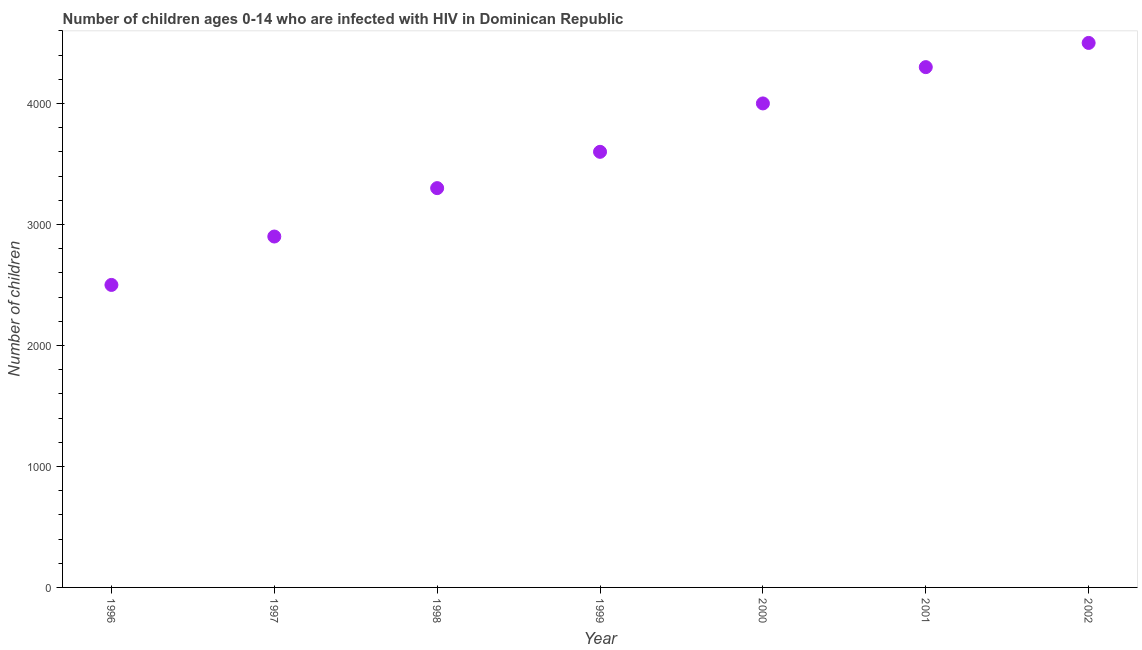What is the number of children living with hiv in 1997?
Your response must be concise. 2900. Across all years, what is the maximum number of children living with hiv?
Your answer should be compact. 4500. Across all years, what is the minimum number of children living with hiv?
Keep it short and to the point. 2500. In which year was the number of children living with hiv maximum?
Your answer should be compact. 2002. In which year was the number of children living with hiv minimum?
Offer a very short reply. 1996. What is the sum of the number of children living with hiv?
Keep it short and to the point. 2.51e+04. What is the difference between the number of children living with hiv in 1998 and 2002?
Your answer should be compact. -1200. What is the average number of children living with hiv per year?
Ensure brevity in your answer.  3585.71. What is the median number of children living with hiv?
Your answer should be compact. 3600. Do a majority of the years between 2001 and 1996 (inclusive) have number of children living with hiv greater than 1800 ?
Your answer should be compact. Yes. What is the ratio of the number of children living with hiv in 1996 to that in 1998?
Provide a short and direct response. 0.76. Is the number of children living with hiv in 1997 less than that in 2001?
Make the answer very short. Yes. Is the difference between the number of children living with hiv in 2001 and 2002 greater than the difference between any two years?
Make the answer very short. No. What is the difference between the highest and the lowest number of children living with hiv?
Keep it short and to the point. 2000. Does the number of children living with hiv monotonically increase over the years?
Your answer should be compact. Yes. Are the values on the major ticks of Y-axis written in scientific E-notation?
Offer a terse response. No. Does the graph contain any zero values?
Your response must be concise. No. Does the graph contain grids?
Offer a terse response. No. What is the title of the graph?
Keep it short and to the point. Number of children ages 0-14 who are infected with HIV in Dominican Republic. What is the label or title of the X-axis?
Keep it short and to the point. Year. What is the label or title of the Y-axis?
Offer a very short reply. Number of children. What is the Number of children in 1996?
Your answer should be compact. 2500. What is the Number of children in 1997?
Provide a succinct answer. 2900. What is the Number of children in 1998?
Make the answer very short. 3300. What is the Number of children in 1999?
Your answer should be very brief. 3600. What is the Number of children in 2000?
Keep it short and to the point. 4000. What is the Number of children in 2001?
Ensure brevity in your answer.  4300. What is the Number of children in 2002?
Your answer should be compact. 4500. What is the difference between the Number of children in 1996 and 1997?
Ensure brevity in your answer.  -400. What is the difference between the Number of children in 1996 and 1998?
Make the answer very short. -800. What is the difference between the Number of children in 1996 and 1999?
Your answer should be compact. -1100. What is the difference between the Number of children in 1996 and 2000?
Give a very brief answer. -1500. What is the difference between the Number of children in 1996 and 2001?
Your answer should be compact. -1800. What is the difference between the Number of children in 1996 and 2002?
Provide a succinct answer. -2000. What is the difference between the Number of children in 1997 and 1998?
Your answer should be compact. -400. What is the difference between the Number of children in 1997 and 1999?
Offer a terse response. -700. What is the difference between the Number of children in 1997 and 2000?
Provide a short and direct response. -1100. What is the difference between the Number of children in 1997 and 2001?
Your response must be concise. -1400. What is the difference between the Number of children in 1997 and 2002?
Offer a terse response. -1600. What is the difference between the Number of children in 1998 and 1999?
Your answer should be very brief. -300. What is the difference between the Number of children in 1998 and 2000?
Offer a very short reply. -700. What is the difference between the Number of children in 1998 and 2001?
Keep it short and to the point. -1000. What is the difference between the Number of children in 1998 and 2002?
Offer a terse response. -1200. What is the difference between the Number of children in 1999 and 2000?
Your answer should be compact. -400. What is the difference between the Number of children in 1999 and 2001?
Give a very brief answer. -700. What is the difference between the Number of children in 1999 and 2002?
Offer a very short reply. -900. What is the difference between the Number of children in 2000 and 2001?
Your answer should be compact. -300. What is the difference between the Number of children in 2000 and 2002?
Provide a short and direct response. -500. What is the difference between the Number of children in 2001 and 2002?
Ensure brevity in your answer.  -200. What is the ratio of the Number of children in 1996 to that in 1997?
Provide a short and direct response. 0.86. What is the ratio of the Number of children in 1996 to that in 1998?
Make the answer very short. 0.76. What is the ratio of the Number of children in 1996 to that in 1999?
Your response must be concise. 0.69. What is the ratio of the Number of children in 1996 to that in 2000?
Make the answer very short. 0.62. What is the ratio of the Number of children in 1996 to that in 2001?
Your response must be concise. 0.58. What is the ratio of the Number of children in 1996 to that in 2002?
Offer a terse response. 0.56. What is the ratio of the Number of children in 1997 to that in 1998?
Offer a very short reply. 0.88. What is the ratio of the Number of children in 1997 to that in 1999?
Give a very brief answer. 0.81. What is the ratio of the Number of children in 1997 to that in 2000?
Your response must be concise. 0.72. What is the ratio of the Number of children in 1997 to that in 2001?
Make the answer very short. 0.67. What is the ratio of the Number of children in 1997 to that in 2002?
Your response must be concise. 0.64. What is the ratio of the Number of children in 1998 to that in 1999?
Give a very brief answer. 0.92. What is the ratio of the Number of children in 1998 to that in 2000?
Your answer should be very brief. 0.82. What is the ratio of the Number of children in 1998 to that in 2001?
Make the answer very short. 0.77. What is the ratio of the Number of children in 1998 to that in 2002?
Make the answer very short. 0.73. What is the ratio of the Number of children in 1999 to that in 2001?
Keep it short and to the point. 0.84. What is the ratio of the Number of children in 2000 to that in 2002?
Offer a terse response. 0.89. What is the ratio of the Number of children in 2001 to that in 2002?
Your answer should be very brief. 0.96. 